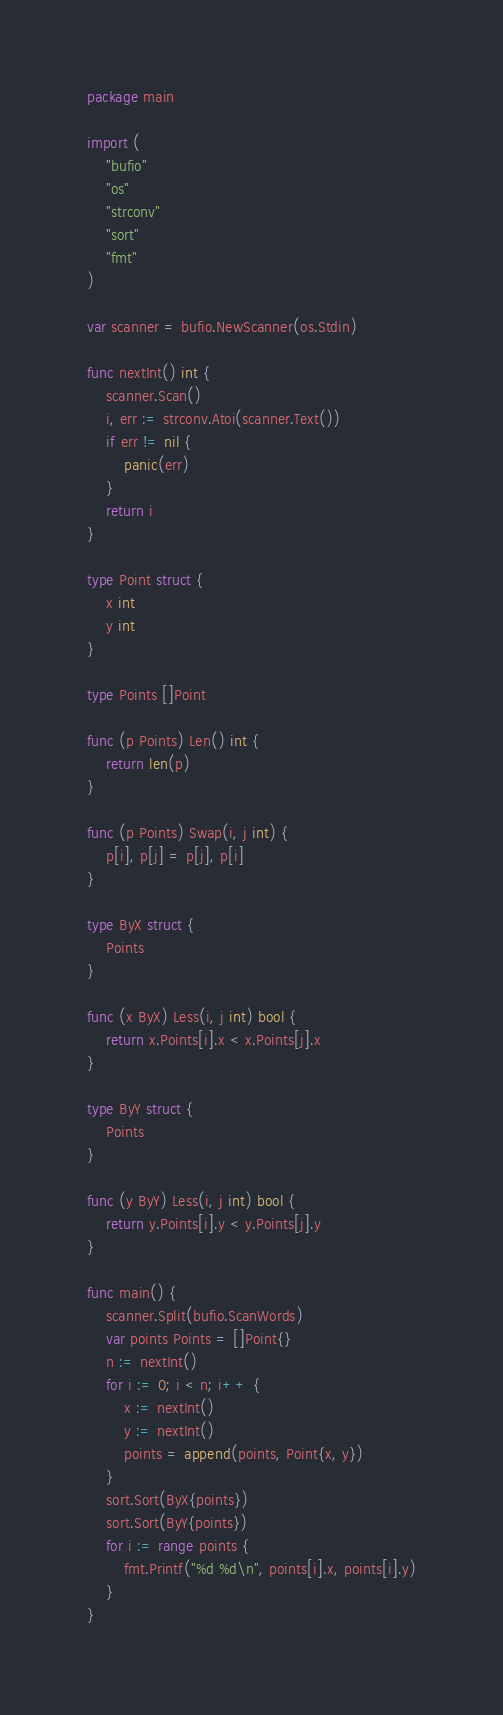<code> <loc_0><loc_0><loc_500><loc_500><_Go_>package main

import (
	"bufio"
	"os"
	"strconv"
	"sort"
	"fmt"
)

var scanner = bufio.NewScanner(os.Stdin)

func nextInt() int {
	scanner.Scan()
	i, err := strconv.Atoi(scanner.Text())
	if err != nil {
		panic(err)
	}
	return i
}

type Point struct {
	x int
	y int
}

type Points []Point

func (p Points) Len() int {
	return len(p)
}

func (p Points) Swap(i, j int) {
	p[i], p[j] = p[j], p[i]
}

type ByX struct {
	Points
}

func (x ByX) Less(i, j int) bool {
	return x.Points[i].x < x.Points[j].x
}

type ByY struct {
	Points
}

func (y ByY) Less(i, j int) bool {
	return y.Points[i].y < y.Points[j].y
}

func main() {
	scanner.Split(bufio.ScanWords)
	var points Points = []Point{}
	n := nextInt()
	for i := 0; i < n; i++ {
		x := nextInt()
		y := nextInt()
		points = append(points, Point{x, y})
	}
	sort.Sort(ByX{points})
	sort.Sort(ByY{points})
	for i := range points {
		fmt.Printf("%d %d\n", points[i].x, points[i].y)
	}
}
</code> 